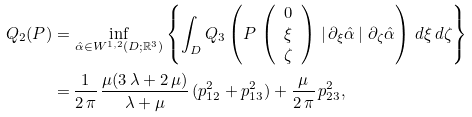Convert formula to latex. <formula><loc_0><loc_0><loc_500><loc_500>Q _ { 2 } ( P ) = & \, \inf _ { \hat { \alpha } \in W ^ { 1 , 2 } ( D ; \mathbb { R } ^ { 3 } ) } \left \{ \int _ { D } Q _ { 3 } \left ( P \, \left ( \begin{array} { c } 0 \\ \xi \\ \zeta \end{array} \right ) \, \left | \, \partial _ { \xi } \hat { \alpha } \, \right | \, \partial _ { \zeta } \hat { \alpha } \right ) \, d \xi \, d \zeta \right \} \\ = & \, \frac { 1 } { 2 \, \pi } \, \frac { \mu ( 3 \, \lambda + 2 \, \mu ) } { \lambda + \mu } \, ( p _ { 1 2 } ^ { 2 } + p _ { 1 3 } ^ { 2 } ) + \frac { \mu } { 2 \, \pi } \, p _ { 2 3 } ^ { 2 } ,</formula> 